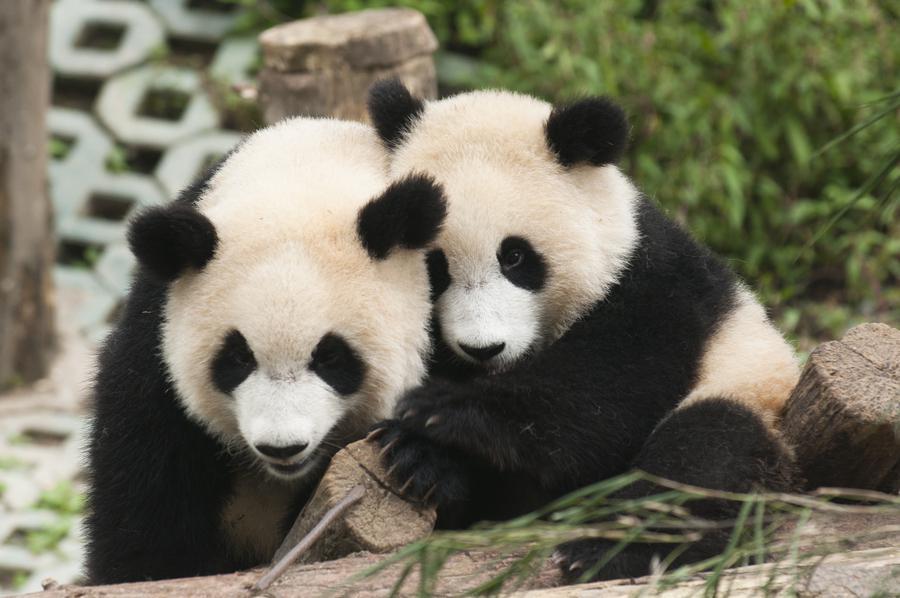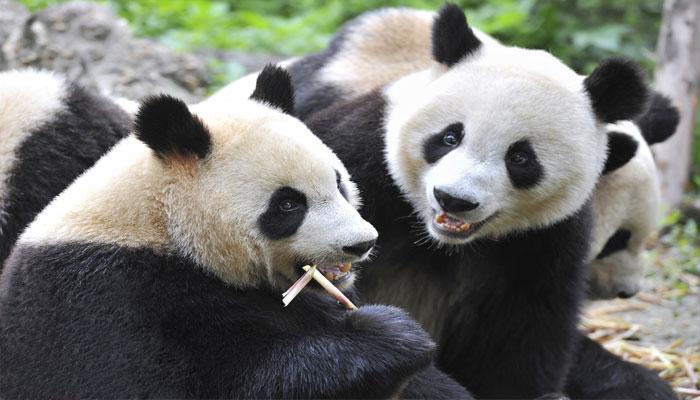The first image is the image on the left, the second image is the image on the right. Evaluate the accuracy of this statement regarding the images: "There are no more than three pandas.". Is it true? Answer yes or no. No. The first image is the image on the left, the second image is the image on the right. Examine the images to the left and right. Is the description "Right image contains twice as many panda bears as the left image." accurate? Answer yes or no. No. 